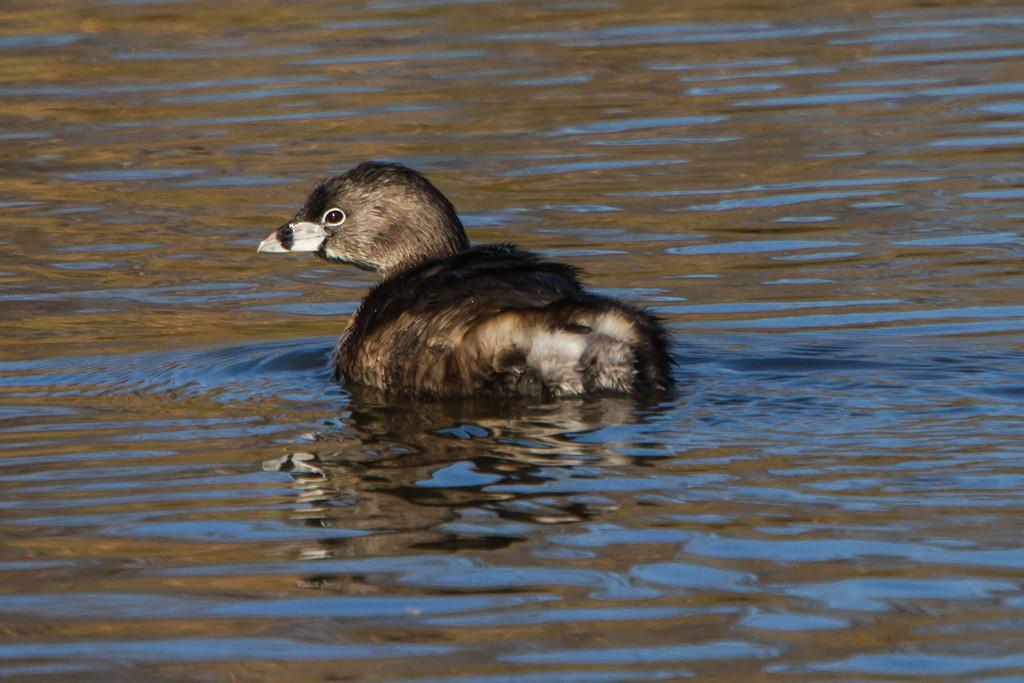What type of animal can be seen in the image? There is a bird in the image. Where is the bird located in the image? The bird is in the water. What part of the bird is missing in the image? There is no indication that any part of the bird is missing in the image. What type of bomb can be seen in the image? There is no bomb present in the image; it features a bird in the water. 